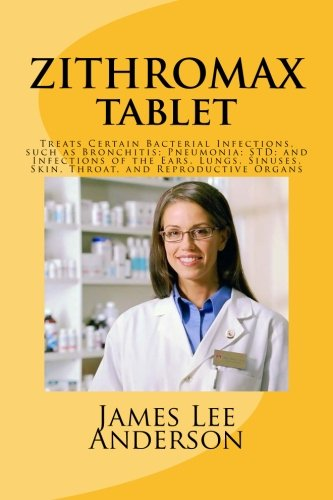What can you infer about the target audience for this book? The target audience may include medical professionals, pharmacy students, or individuals seeking detailed information on Zithromax's uses and properties. 